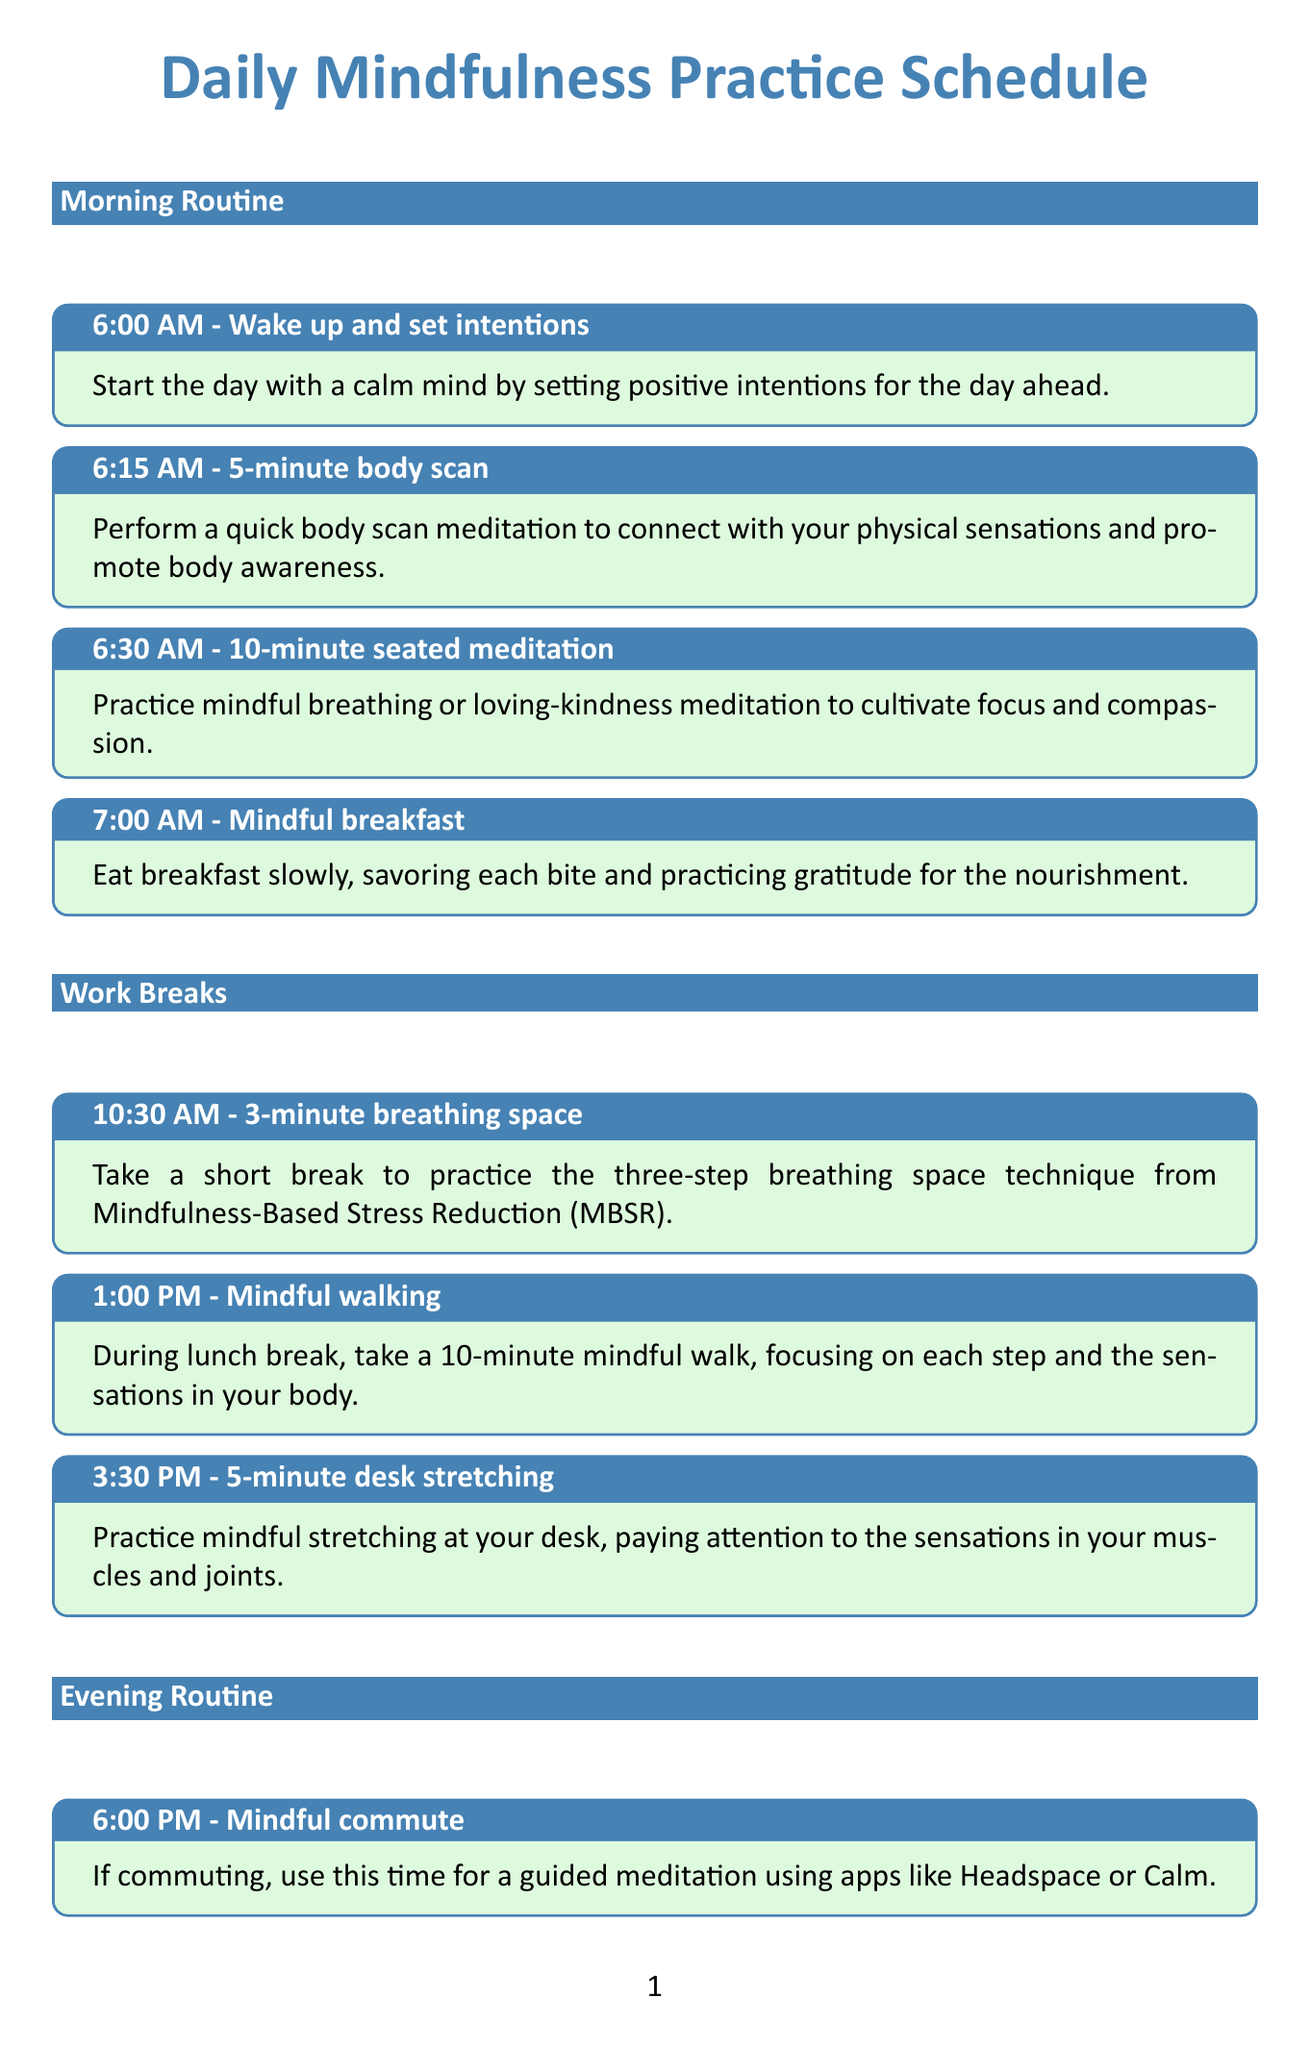What time does the morning routine start? The morning routine begins at 6:00 AM as indicated in the document.
Answer: 6:00 AM How long is the 10-minute seated meditation? The duration for the seated meditation activity mentioned is 10 minutes.
Answer: 10 minutes What activity is scheduled right after breakfast? The activity following breakfast is a 10-minute seated meditation, which focuses on mindful breathing or loving-kindness meditation.
Answer: 10-minute seated meditation What is the first activity in the bedtime rituals? The first activity during the bedtime rituals is a digital detox at 9:30 PM.
Answer: Digital detox How many minutes is allocated for the progressive muscle relaxation? The documentation specifies a 10-minute duration for the progressive muscle relaxation.
Answer: 10 minutes In which routine does mindful walking occur? Mindful walking is included in the work breaks section of the schedule.
Answer: Work breaks How many gratitude reflections are suggested in the bedtime rituals? The bedtime rituals suggest reflecting on three things you're grateful for from the day.
Answer: Three things What specific time is allocated for the mindful commute? The document states the mindful commute begins at 6:00 PM.
Answer: 6:00 PM What type of meditation is suggested during the bedtime meditation? The suggested meditation for bedtime is a sleep-focused guided meditation.
Answer: Sleep-focused guided meditation 